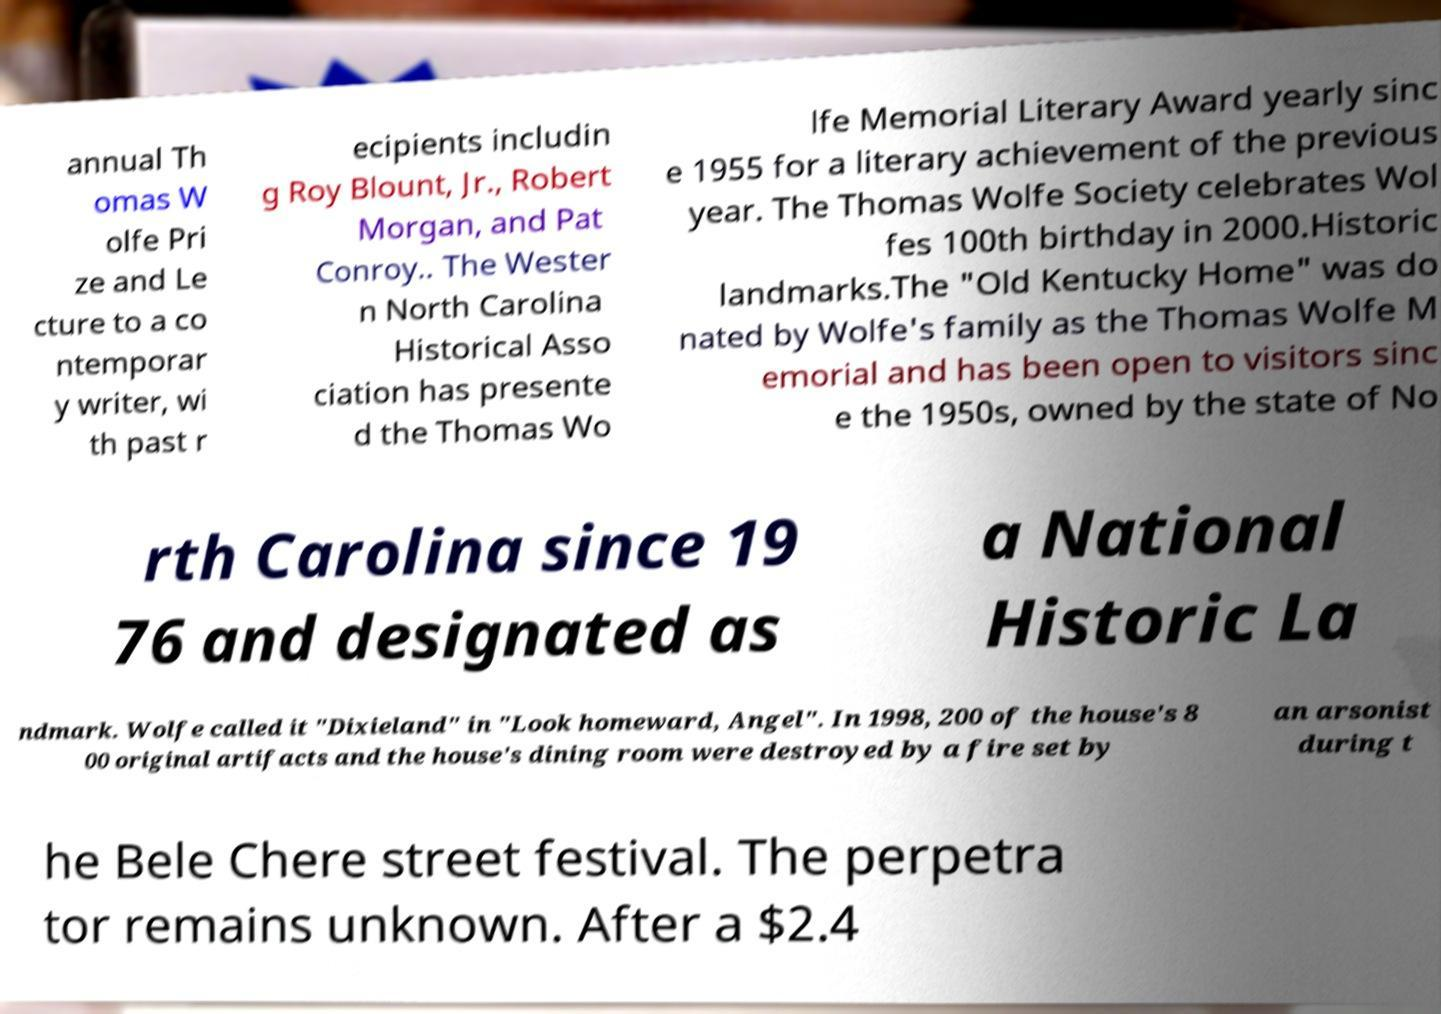What messages or text are displayed in this image? I need them in a readable, typed format. annual Th omas W olfe Pri ze and Le cture to a co ntemporar y writer, wi th past r ecipients includin g Roy Blount, Jr., Robert Morgan, and Pat Conroy.. The Wester n North Carolina Historical Asso ciation has presente d the Thomas Wo lfe Memorial Literary Award yearly sinc e 1955 for a literary achievement of the previous year. The Thomas Wolfe Society celebrates Wol fes 100th birthday in 2000.Historic landmarks.The "Old Kentucky Home" was do nated by Wolfe's family as the Thomas Wolfe M emorial and has been open to visitors sinc e the 1950s, owned by the state of No rth Carolina since 19 76 and designated as a National Historic La ndmark. Wolfe called it "Dixieland" in "Look homeward, Angel". In 1998, 200 of the house's 8 00 original artifacts and the house's dining room were destroyed by a fire set by an arsonist during t he Bele Chere street festival. The perpetra tor remains unknown. After a $2.4 